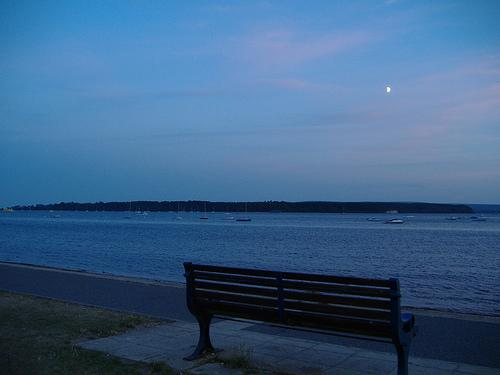Write a vivid description focusing on the most prominent element in the image. A weathered wooden bench sits by the coastline, overlooking the serene body of water where sailboats and engine boats calmly navigate through the waves. Focus on the vegetation and ground elements present in the picture. Asphalt path along the waterfront with grass and weeds growing in the concrete under the bench create a sense of nature persisting amidst human-made structures. Mention the key objects found in the image, along with their approximate positions. There is an outdoor bench near the coast, sailboats and engine boats on the water, a half moon in the sky, an island across the bay, and a running path next to the coast. Describe the sky and what elements can be seen in it. A beautiful blue sky filled with a scattering of white, whispy clouds and the subtle appearance of a half moon nestled among them. Write a concise description of the location where the image was taken. A coastal area featuring a wooden bench, running path, sailboats, engine boats, an island in the distance, and a sky with clouds and a half moon. Using a poetic tone, describe the scenery displayed in the image. Beside the coast, a lonely bench awaits, watching sailboats dance with engine boats on shimmering waters, as the half moon peeks through a tapestry of whispy clouds in the tranquil sky. Describe the image as if you are a tour guide explaining it to a group of tourists. In this scenic location, you'll find a charming wooden bench by the coast, offering a perfect view of sailboats and engine boats on the water, an island in the distance, and a sky graced by clouds and a half moon. Summarize the atmosphere and the different elements present in the image. A serene coastal setting with a wooden bench, sailboats, engine boats, an island in the distance, and a beautiful sky adorned with clouds and a half moon. Write a short description of the scene from the perspective of someone sitting on the bench. From the bench by the ocean, one can admire a peaceful view of sailboats and engine boats sailing the waters, an island in the distance, and a picturesque sky with a half moon. Describe the scene as if you are writing a brief travel brochure recommendation. Take a leisurely stroll along the picturesque waterfront path, pausing at the wooden bench to admire sailboats, an island in the distance, and the captivating sky with a half moon. 